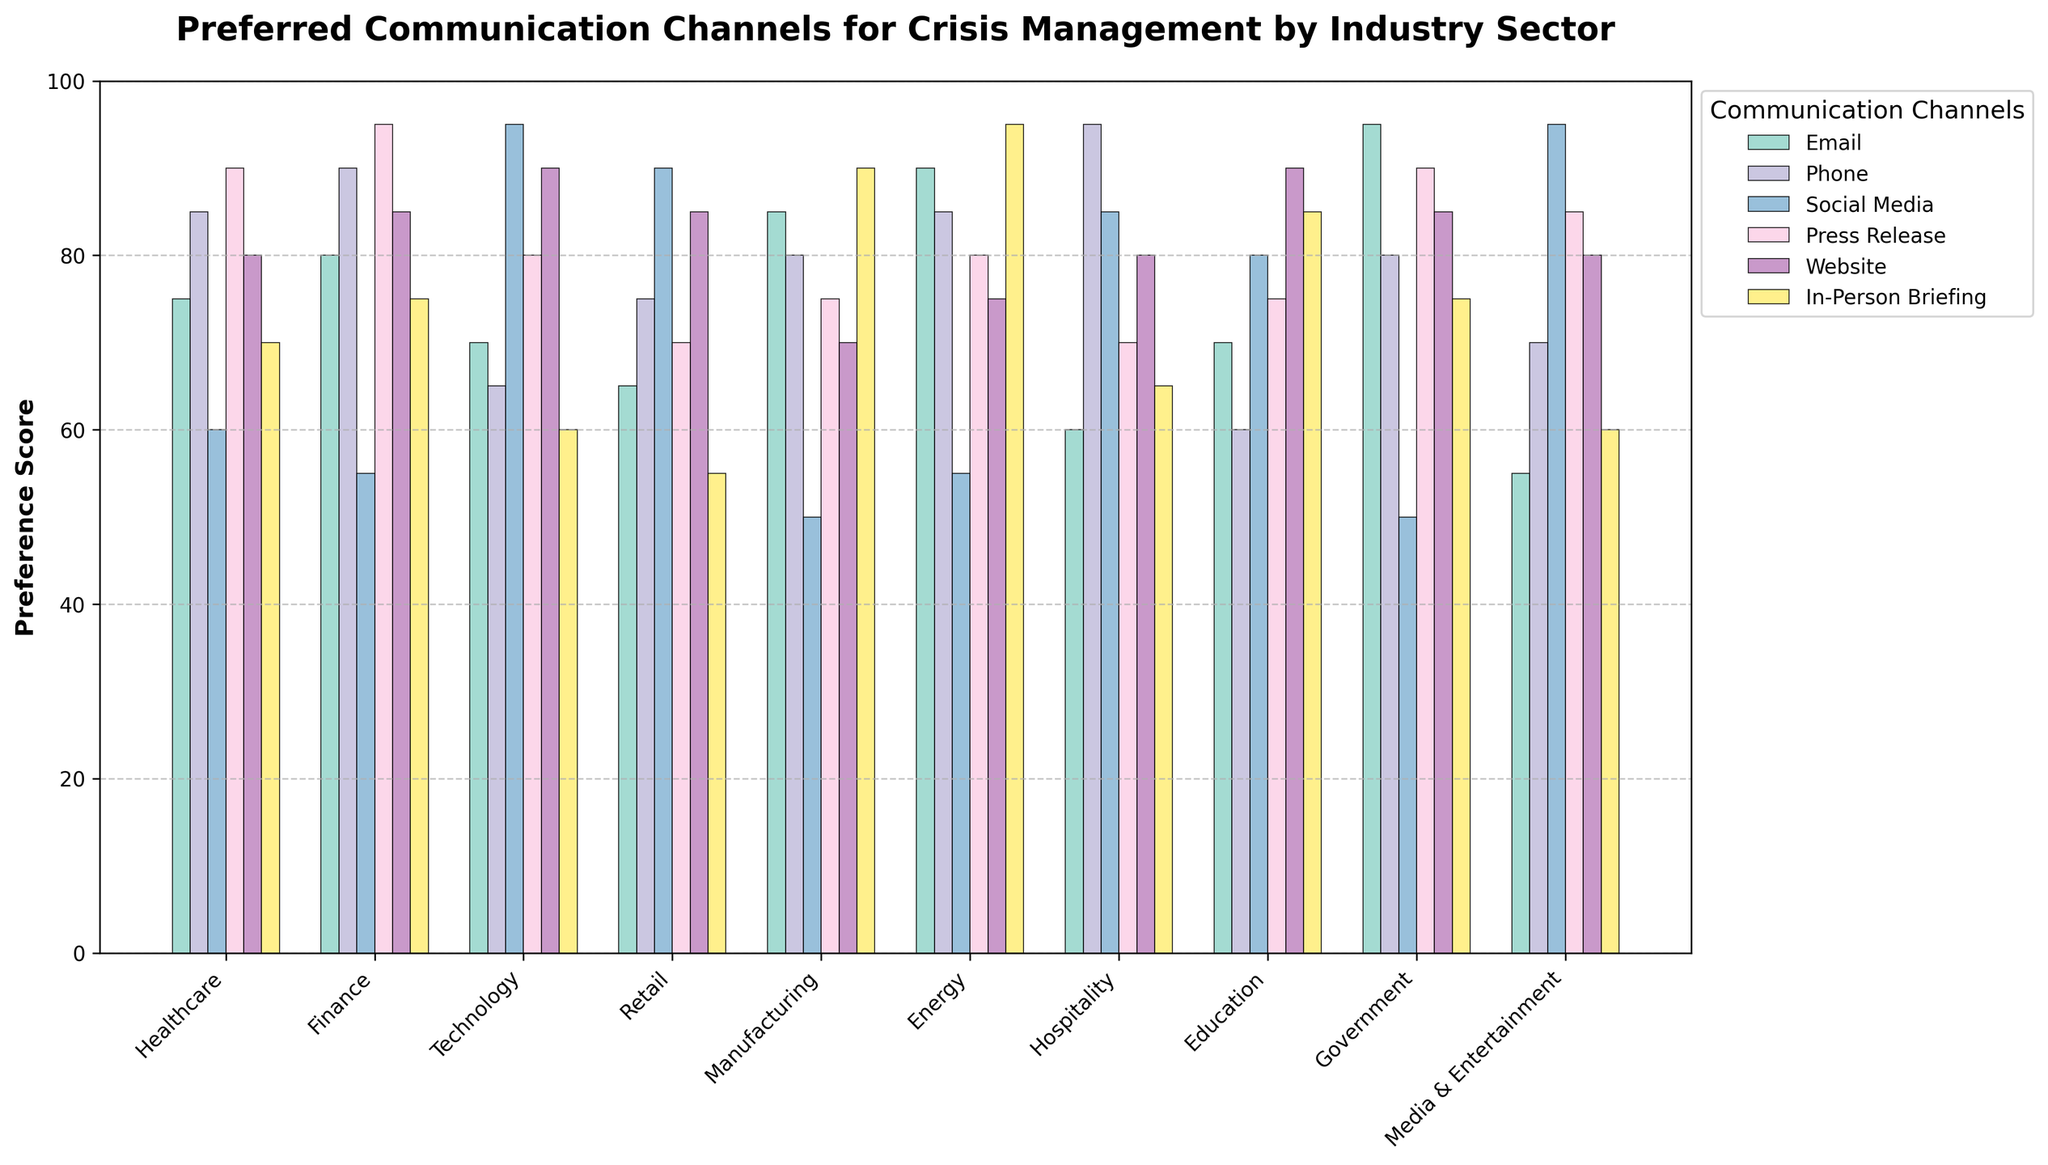Which industry prefers Social Media the most for crisis management? Examine the tallest bar in the Social Media section. The highest value is 95 for Technology and Media & Entertainment industries.
Answer: Technology and Media & Entertainment Which industry prefers In-Person Briefing the most? Look for the industry with the tallest bar in the In-Person Briefing section. The highest value is 95 for the Energy sector.
Answer: Energy How does the preference for Phone communication in the Hospitality sector compare to the Finance sector? Identify the height of the bars representing the Phone preference in both sectors. In Hospitality, it's 95, and in Finance, it's 90. Therefore, Hospitality prefers Phone communication slightly more than Finance.
Answer: Hospitality prefers more What is the average preference score for Website communication across all industries? Sum all the values for the Website communication (80 + 85 + 90 + 85 + 70 + 75 + 80 + 90 + 85 + 80 = 820). Then, divide by the number of industries (10). The average is 820/10 = 82.
Answer: 82 Which industry has the highest overall preference for communication channels? Sum all the preference scores for each industry and find the highest total. E.g., Healthcare: 75+85+60+90+80+70 = 460, Finance: 80+90+55+95+85+75 = 480, etc. Government has the highest total at 475.
Answer: Finance Is there an industry that prefers Email communication more than 90? Check if any bar in the Email section exceeds 90. None of the industries have a score higher than 90 for Email communication.
Answer: No Which two industries have the closest preference for Press Release communication? Compare the heights of the bars in the Press Release section and find the closest values. Retail (70) and Manufacturing (75) have a 5-point difference.
Answer: Retail and Manufacturing How does the preference for Social Media in Technology compare to In-Person Briefing in Manufacturing? Identify the heights for Social Media in Technology and In-Person Briefing in Manufacturing. Both have a score of 90.
Answer: Equal What's the difference in preference for Website communication between Technology and Energy? Subtract the Website score of Technology (90) from Energy (75). The difference is 15.
Answer: 15 